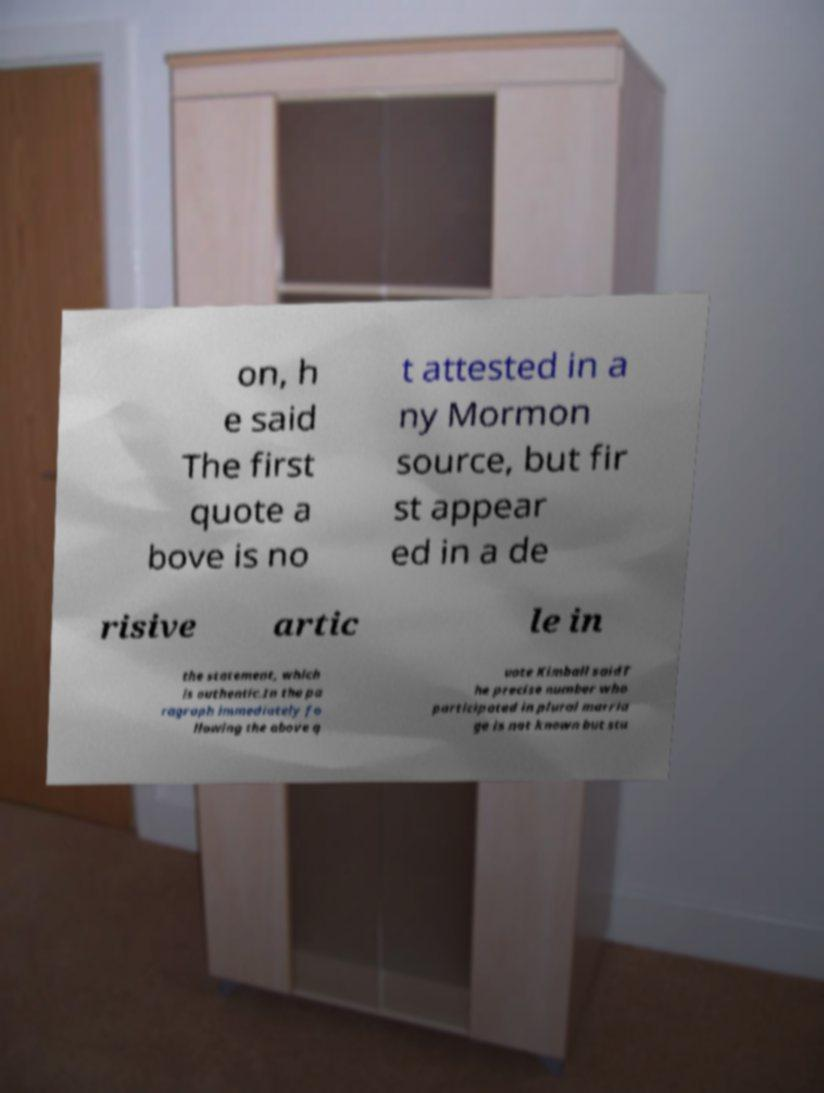What messages or text are displayed in this image? I need them in a readable, typed format. on, h e said The first quote a bove is no t attested in a ny Mormon source, but fir st appear ed in a de risive artic le in the statement, which is authentic.In the pa ragraph immediately fo llowing the above q uote Kimball saidT he precise number who participated in plural marria ge is not known but stu 